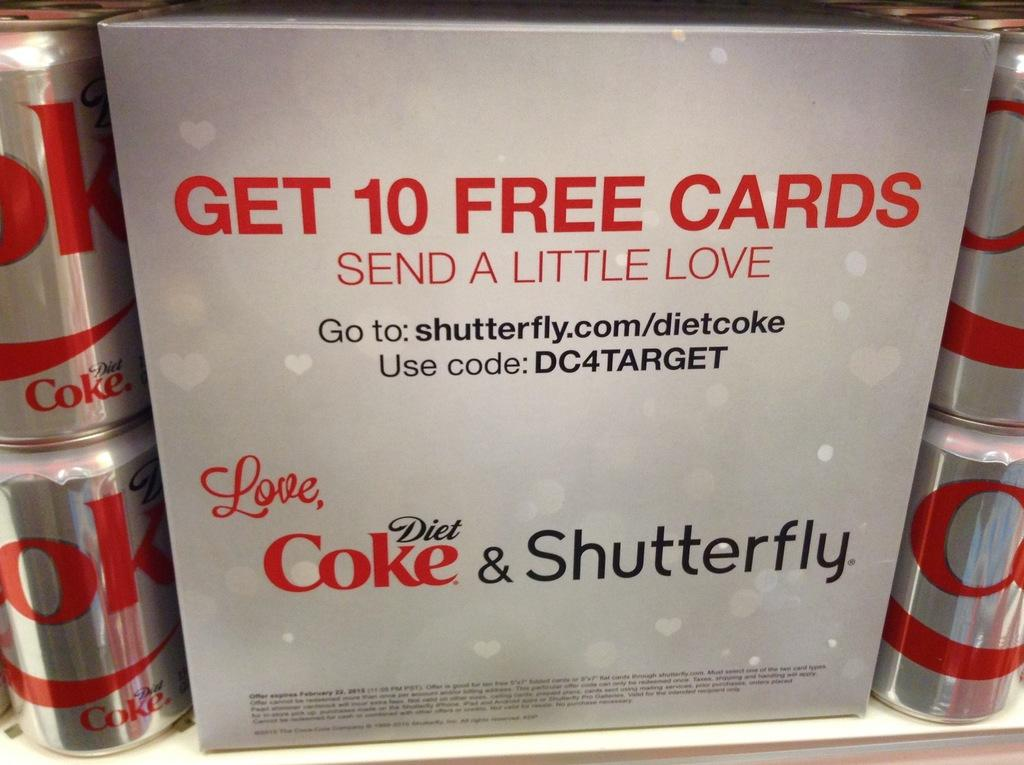Provide a one-sentence caption for the provided image. A display of diet cokes telling how to get ten free cards. 